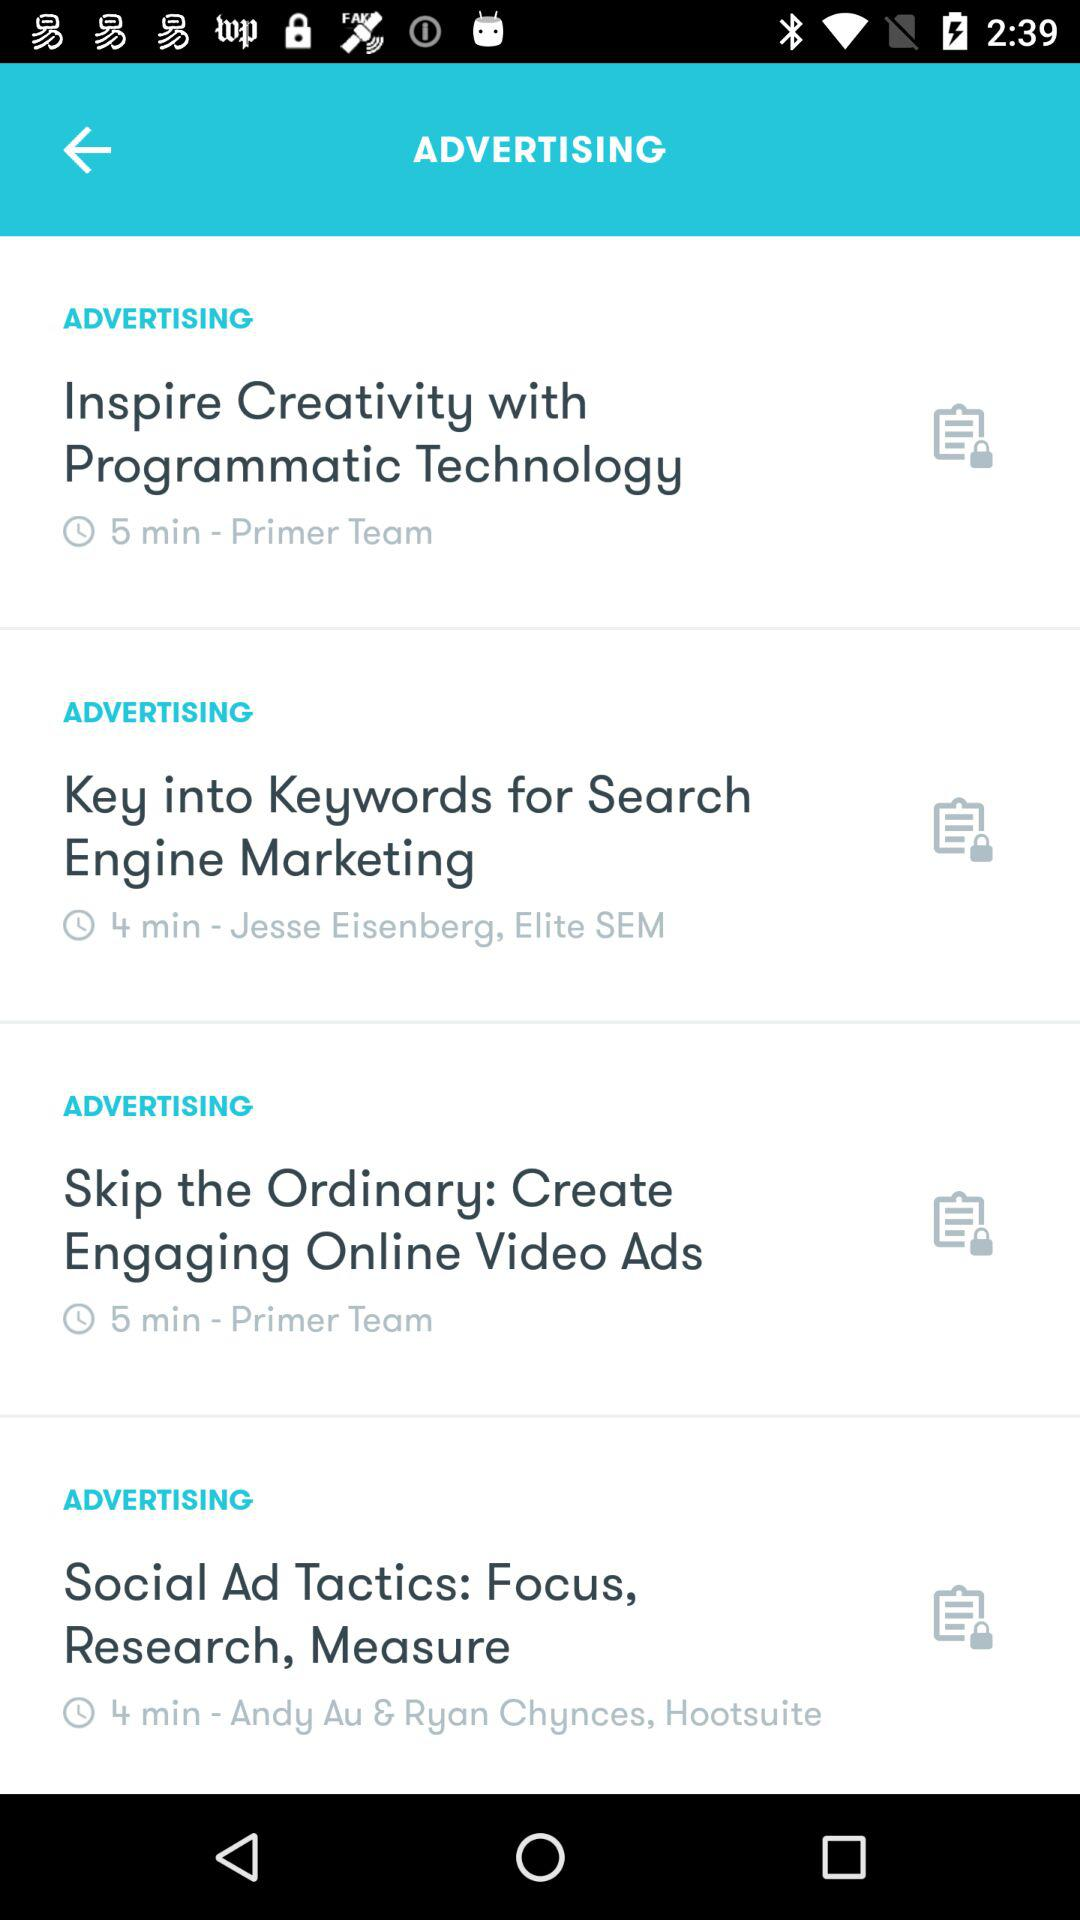What is the duration of the "Key into Keywords for Search Engine Marketing"? The duration is 4 minutes. 